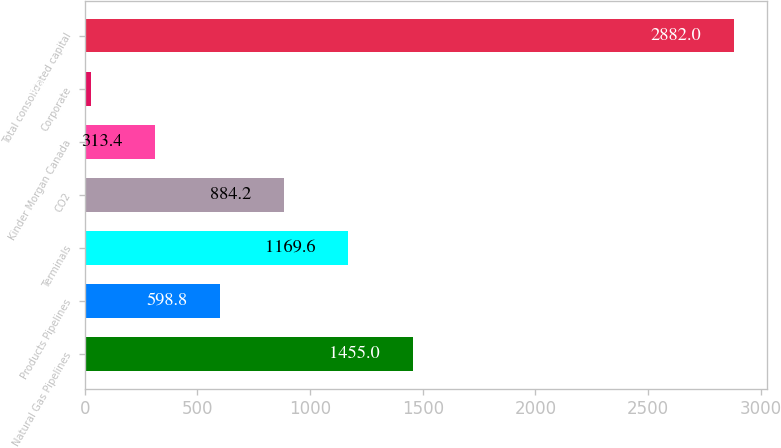<chart> <loc_0><loc_0><loc_500><loc_500><bar_chart><fcel>Natural Gas Pipelines<fcel>Products Pipelines<fcel>Terminals<fcel>CO2<fcel>Kinder Morgan Canada<fcel>Corporate<fcel>Total consolidated capital<nl><fcel>1455<fcel>598.8<fcel>1169.6<fcel>884.2<fcel>313.4<fcel>28<fcel>2882<nl></chart> 